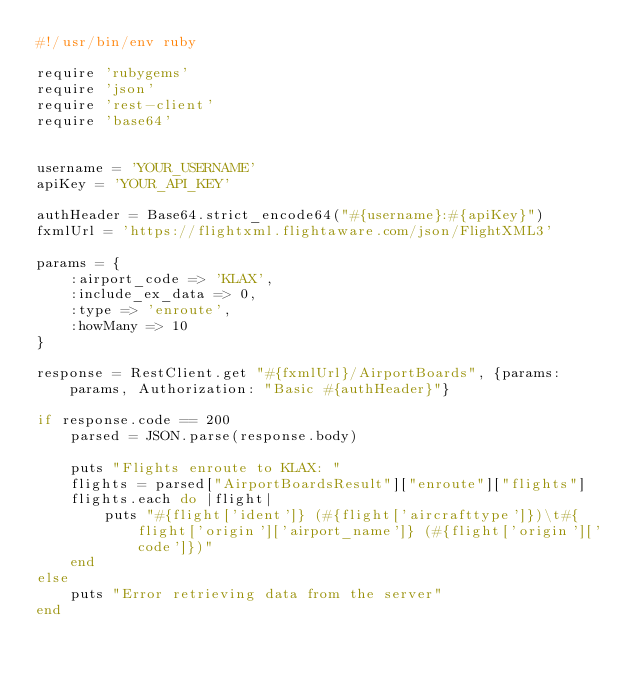Convert code to text. <code><loc_0><loc_0><loc_500><loc_500><_Ruby_>#!/usr/bin/env ruby

require 'rubygems'
require 'json'
require 'rest-client'
require 'base64'


username = 'YOUR_USERNAME'
apiKey = 'YOUR_API_KEY'

authHeader = Base64.strict_encode64("#{username}:#{apiKey}")
fxmlUrl = 'https://flightxml.flightaware.com/json/FlightXML3'

params = {
	:airport_code => 'KLAX',
	:include_ex_data => 0,
	:type => 'enroute',
	:howMany => 10
}

response = RestClient.get "#{fxmlUrl}/AirportBoards", {params: params, Authorization: "Basic #{authHeader}"}

if response.code == 200
	parsed = JSON.parse(response.body)

	puts "Flights enroute to KLAX: "
	flights = parsed["AirportBoardsResult"]["enroute"]["flights"]
	flights.each do |flight|
		puts "#{flight['ident']} (#{flight['aircrafttype']})\t#{flight['origin']['airport_name']} (#{flight['origin']['code']})"
	end
else
	puts "Error retrieving data from the server"
end</code> 